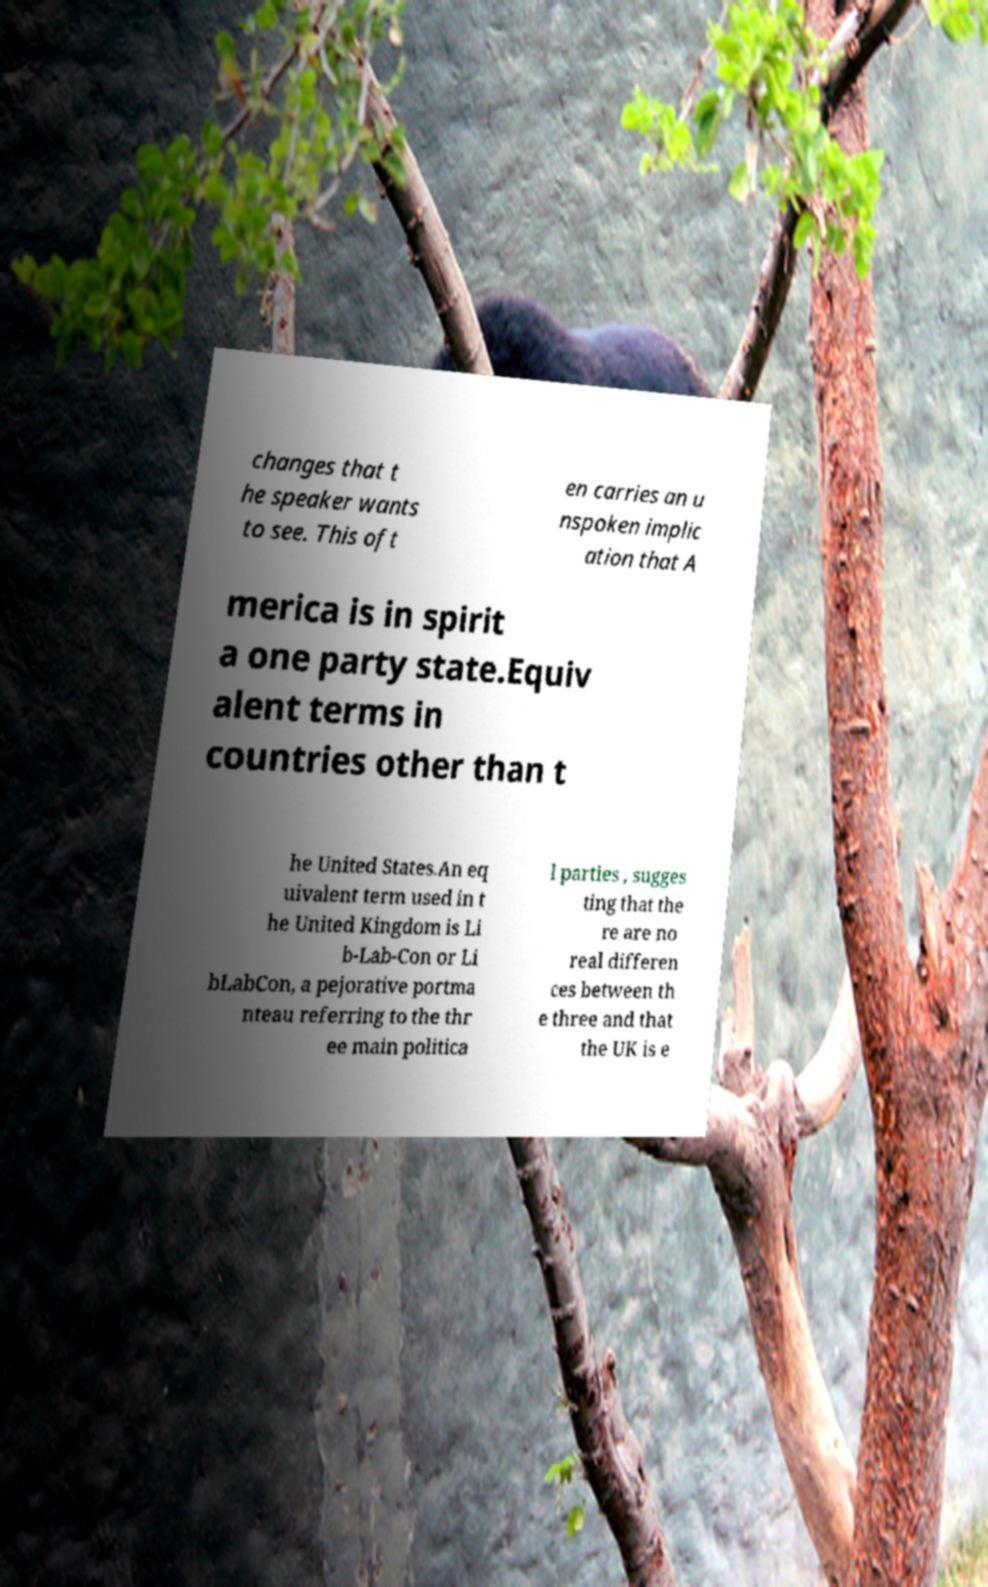Could you extract and type out the text from this image? changes that t he speaker wants to see. This oft en carries an u nspoken implic ation that A merica is in spirit a one party state.Equiv alent terms in countries other than t he United States.An eq uivalent term used in t he United Kingdom is Li b-Lab-Con or Li bLabCon, a pejorative portma nteau referring to the thr ee main politica l parties , sugges ting that the re are no real differen ces between th e three and that the UK is e 